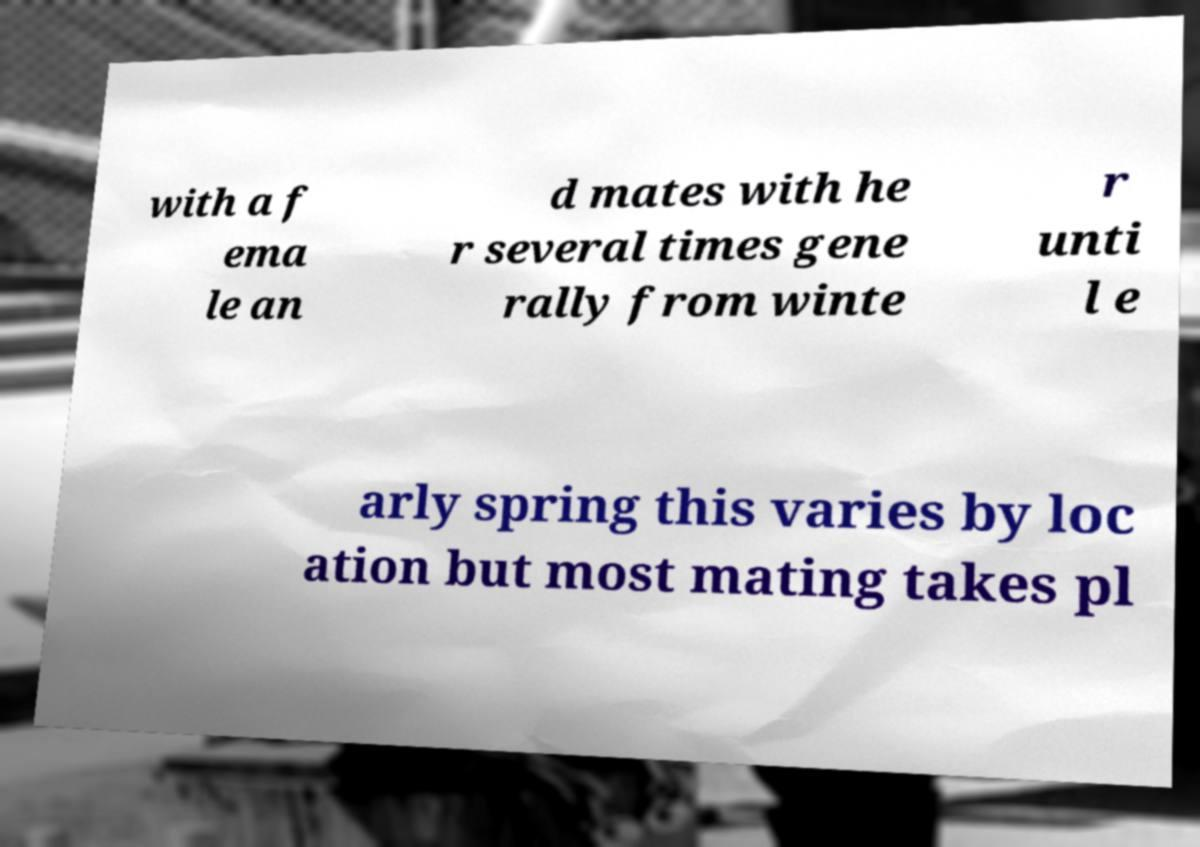Can you accurately transcribe the text from the provided image for me? with a f ema le an d mates with he r several times gene rally from winte r unti l e arly spring this varies by loc ation but most mating takes pl 